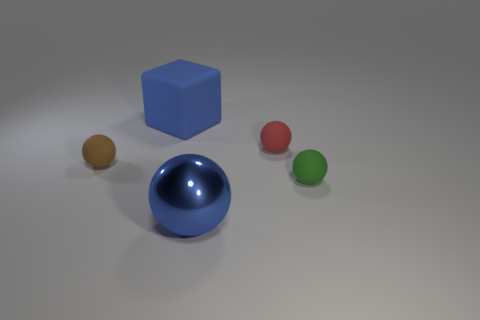Subtract 1 balls. How many balls are left? 3 Subtract all green balls. How many balls are left? 3 Subtract all gray balls. Subtract all cyan cylinders. How many balls are left? 4 Add 1 small brown matte balls. How many objects exist? 6 Subtract all balls. How many objects are left? 1 Subtract 1 brown spheres. How many objects are left? 4 Subtract all tiny red rubber balls. Subtract all metal spheres. How many objects are left? 3 Add 5 tiny things. How many tiny things are left? 8 Add 3 metallic things. How many metallic things exist? 4 